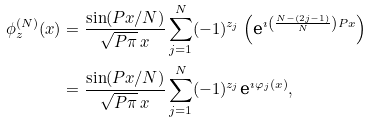Convert formula to latex. <formula><loc_0><loc_0><loc_500><loc_500>\phi _ { z } ^ { ( N ) } ( x ) & = \frac { \sin ( P x / N ) } { \sqrt { P \pi } \, x } \sum _ { j = 1 } ^ { N } ( - 1 ) ^ { z _ { j } } \left ( \text {e} ^ { \imath \left ( \frac { N - ( 2 j - 1 ) } { N } \right ) P x } \right ) \\ & = \frac { \sin ( P x / N ) } { \sqrt { P \pi } \, x } \sum _ { j = 1 } ^ { N } ( - 1 ) ^ { z _ { j } } \text {e} ^ { \imath \varphi _ { j } ( x ) } ,</formula> 